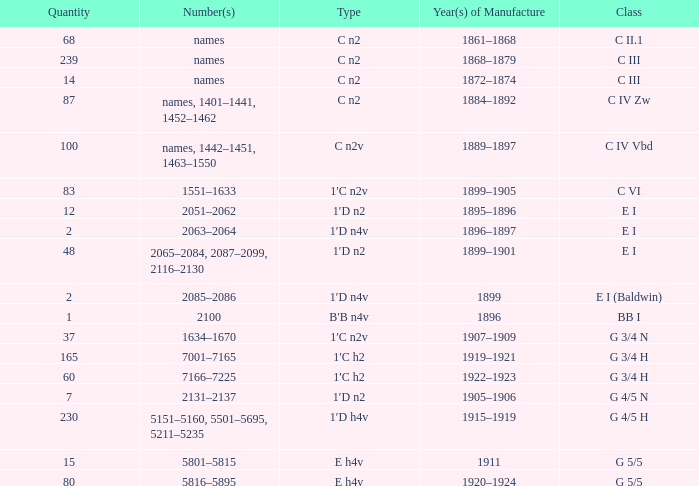Which Quantity has a Type of e h4v, and a Year(s) of Manufacture of 1920–1924? 80.0. 